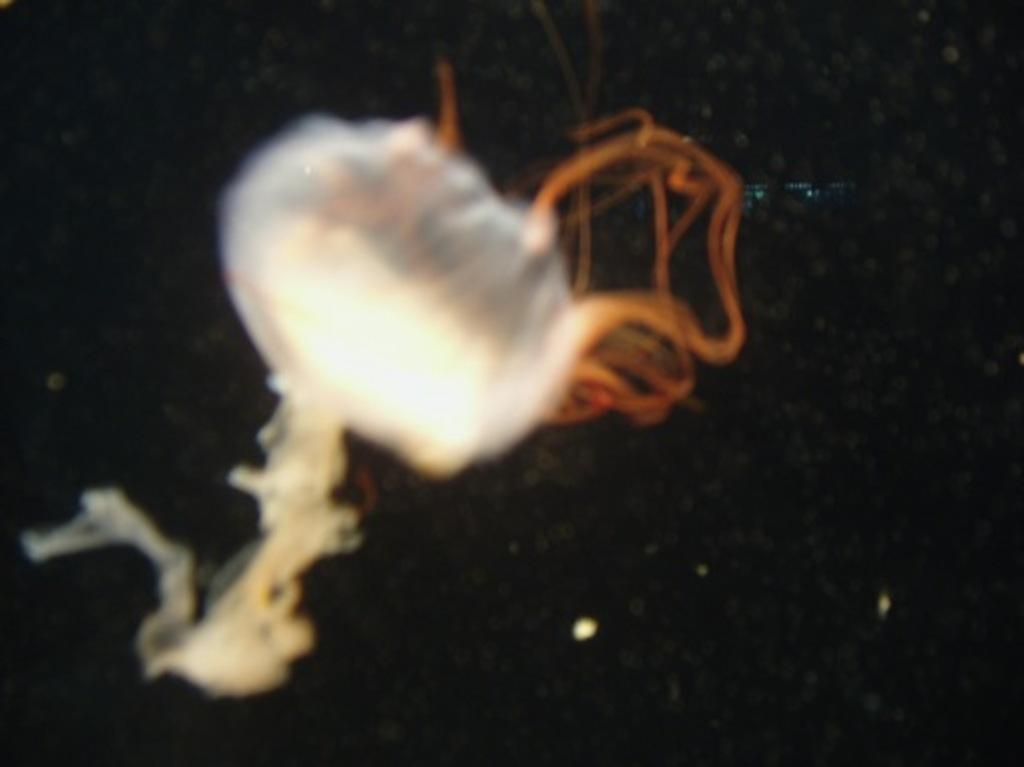What type of marine animals can be seen in the image? There are jellyfish in the image. Are there any other animals present in the image? Yes, there is a fish in the image. Can you describe the colors of the fish? The fish has white, cream, and brown colors. What is the color of the background in the image? The background of the image is dark. How many cattle can be seen grazing in the image? There are no cattle present in the image; it features jellyfish and a fish. What type of eyes does the fish have in the image? The image does not show the fish's eyes, so it cannot be determined from the image. 